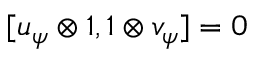Convert formula to latex. <formula><loc_0><loc_0><loc_500><loc_500>[ u _ { \psi } \otimes \mathbb { 1 } , \mathbb { 1 } \otimes v _ { \psi } ] = 0</formula> 